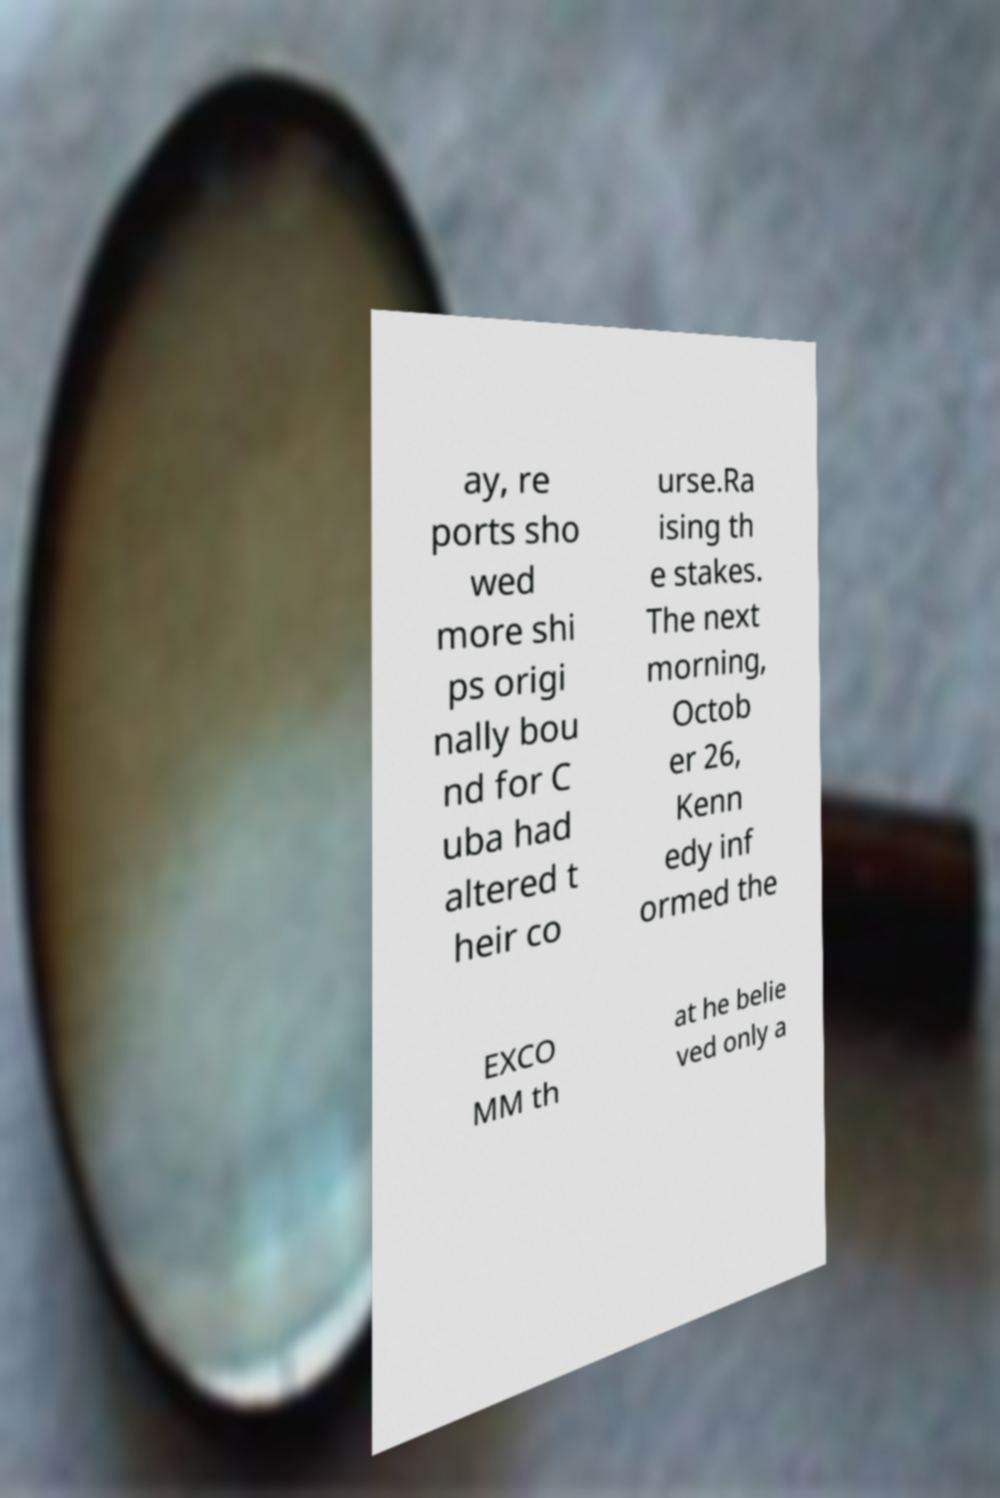Could you assist in decoding the text presented in this image and type it out clearly? ay, re ports sho wed more shi ps origi nally bou nd for C uba had altered t heir co urse.Ra ising th e stakes. The next morning, Octob er 26, Kenn edy inf ormed the EXCO MM th at he belie ved only a 